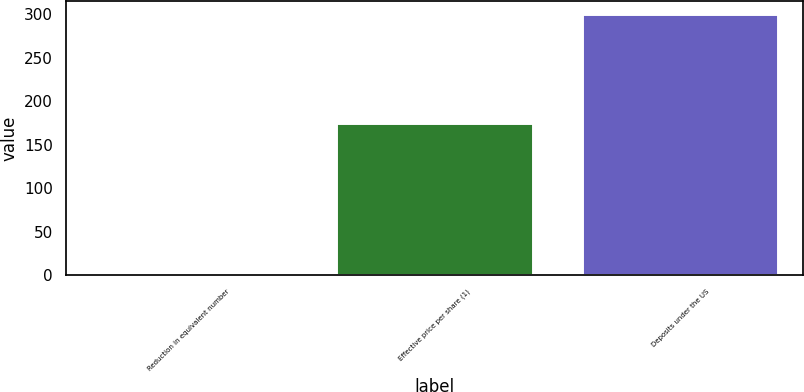Convert chart to OTSL. <chart><loc_0><loc_0><loc_500><loc_500><bar_chart><fcel>Reduction in equivalent number<fcel>Effective price per share (1)<fcel>Deposits under the US<nl><fcel>2<fcel>174.73<fcel>300<nl></chart> 